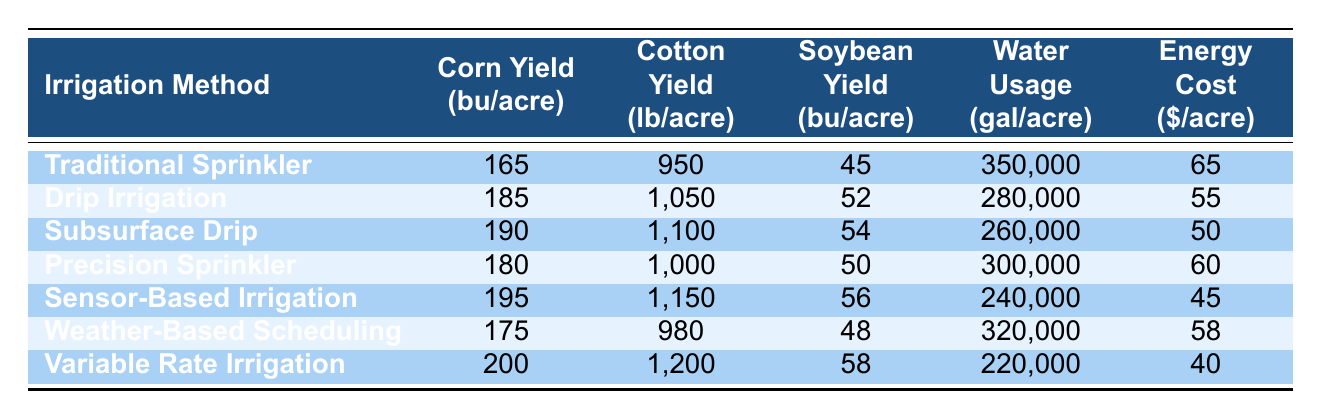What is the highest corn yield achieved with an irrigation method in the table? The highest corn yield in the table is found by looking at the "Corn Yield (bu/acre)" column and identifying the maximum value, which is 200 bu/acre under the "Variable Rate Irrigation" method.
Answer: 200 bu/acre Which irrigation method uses the least amount of water per acre? To find the least water usage, look at the "Water Usage (gal/acre)" column and identify the minimum value, which is 220,000 gal/acre for "Variable Rate Irrigation."
Answer: 220,000 gal/acre Is the yield of cotton higher for Sensor-Based Irrigation compared to Weather-Based Scheduling? Check the values in the "Cotton Yield (lb/acre)" column for both methods; Sensor-Based Irrigation has a yield of 1,150 lb/acre, while Weather-Based Scheduling has a yield of 980 lb/acre. Since 1,150 is greater than 980, the statement is true.
Answer: Yes What is the average soybean yield across all irrigation methods in the table? Add the soybean yields: 45 + 52 + 54 + 50 + 56 + 48 + 58 = 363. There are 7 methods, so divide the total yield by 7, which gives 363/7 ≈ 51.86.
Answer: Approximately 51.86 bu/acre How much more energy cost is incurred by Traditional Sprinkler compared to Variable Rate Irrigation? Look at the "Energy Cost ($/acre)" column for both methods: Traditional Sprinkler costs 65, and Variable Rate Irrigation costs 40. The difference is 65 - 40 = 25.
Answer: 25 dollars/acre Which irrigation method would be most efficient if we consider both yield and water usage? Calculate the yield-to-water usage ratio for each method (yield per gal): Traditional Sprinkler 165/350000, Drip Irrigation 185/280000, Subsurface Drip 190/260000, etc. The highest ratio is for Variable Rate Irrigation with 200/220000, which equals approximately 0.000909.
Answer: Variable Rate Irrigation Is it true that Drip Irrigation has a higher corn yield than Precision Sprinkler? Check the corn yields: Drip Irrigation has a yield of 185 bu/acre and Precision Sprinkler has a yield of 180 bu/acre. Since 185 is greater than 180, the statement is true.
Answer: Yes What is the total water usage for all irrigation methods combined? Add the values in the "Water Usage (gal/acre)" column: 350000 + 280000 + 260000 + 300000 + 240000 + 320000 + 220000 = 1,770,000 gallons.
Answer: 1,770,000 gallons Which irrigation method has the highest cotton yield, and what is that yield? Look at the "Cotton Yield (lb/acre)" column to find the maximum value; it's 1,200 lb/acre for Variable Rate Irrigation.
Answer: Variable Rate Irrigation, 1,200 lb/acre Determine the difference in soybean yield between the best and worst performing methods. Identify soybean yields: Variable Rate Irrigation has the highest at 58 bu/acre and Traditional Sprinkler has the lowest at 45 bu/acre. The difference is 58 - 45 = 13.
Answer: 13 bu/acre Which irrigation method has the lowest energy cost, and what is that cost? Find the minimum value in the "Energy Cost ($/acre)" column, which is 40 dollars for Variable Rate Irrigation.
Answer: Variable Rate Irrigation, 40 dollars 